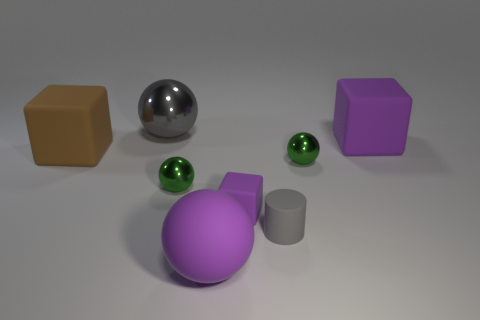Add 2 large blue metallic objects. How many objects exist? 10 Subtract all blocks. How many objects are left? 5 Subtract 1 purple balls. How many objects are left? 7 Subtract all large purple matte spheres. Subtract all gray metal balls. How many objects are left? 6 Add 4 gray metallic things. How many gray metallic things are left? 5 Add 1 green matte cubes. How many green matte cubes exist? 1 